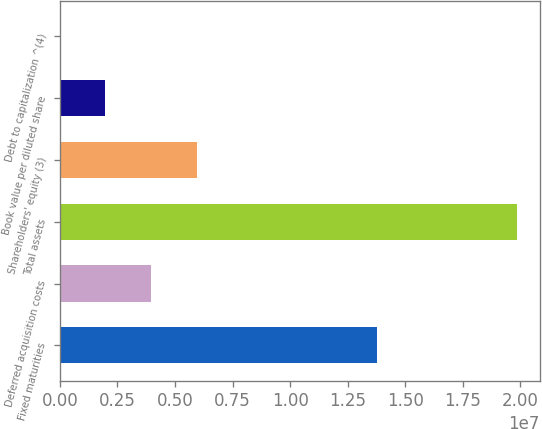Convert chart to OTSL. <chart><loc_0><loc_0><loc_500><loc_500><bar_chart><fcel>Fixed maturities<fcel>Deferred acquisition costs<fcel>Total assets<fcel>Shareholders' equity (3)<fcel>Book value per diluted share<fcel>Debt to capitalization ^(4)<nl><fcel>1.3758e+07<fcel>3.97066e+06<fcel>1.98532e+07<fcel>5.95598e+06<fcel>1.98534e+06<fcel>23.3<nl></chart> 